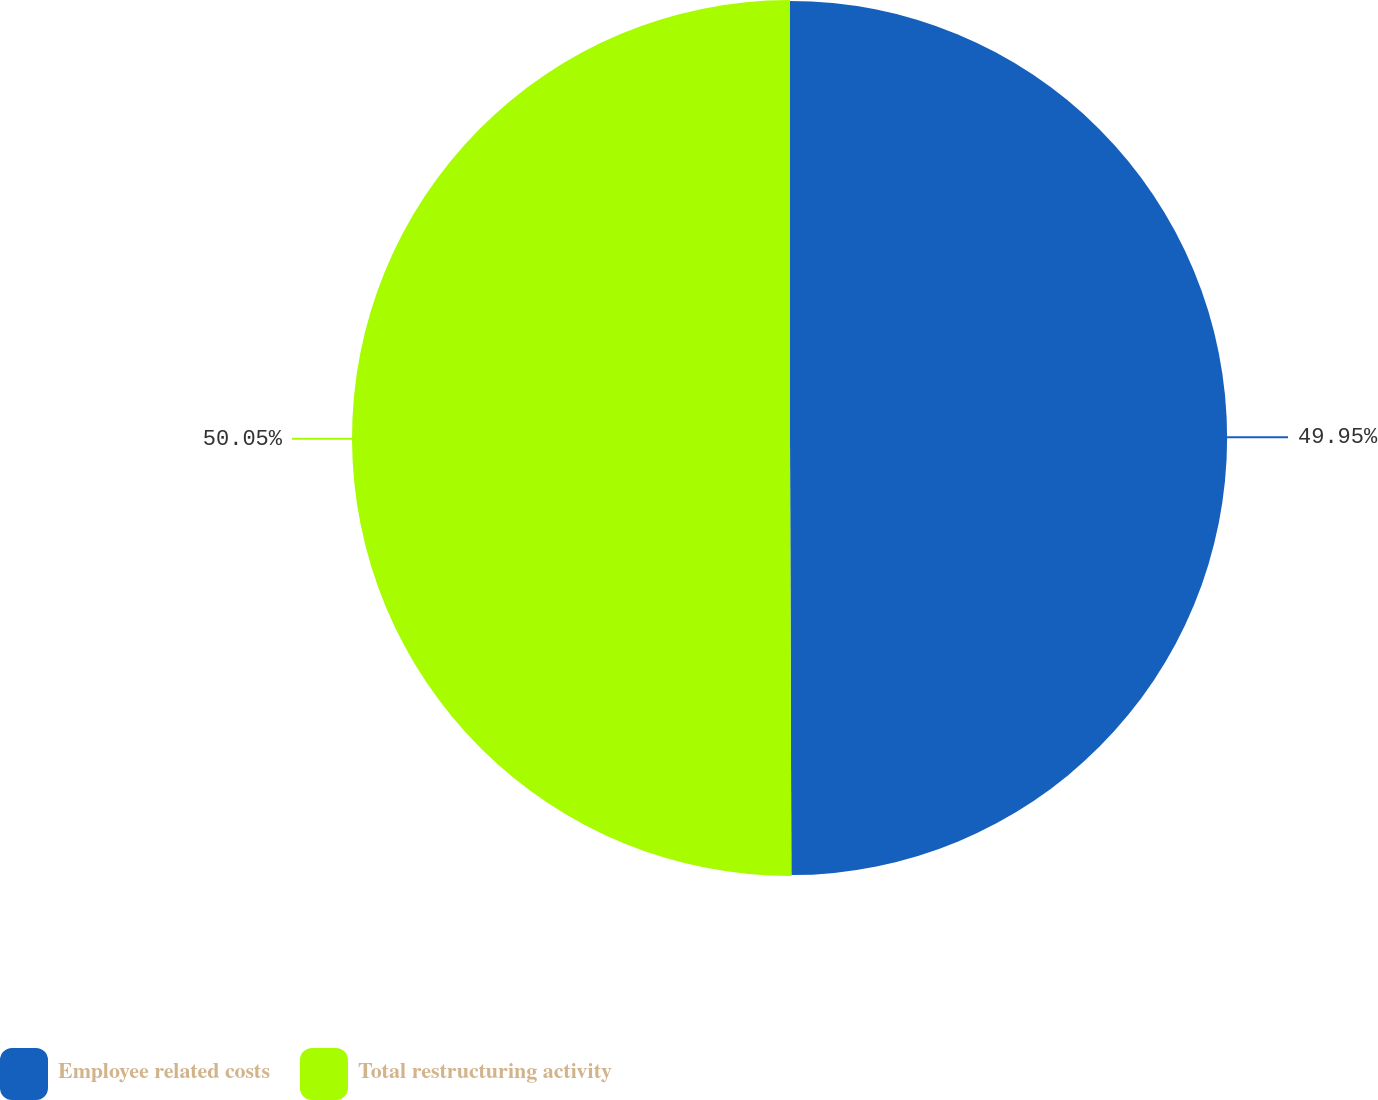<chart> <loc_0><loc_0><loc_500><loc_500><pie_chart><fcel>Employee related costs<fcel>Total restructuring activity<nl><fcel>49.95%<fcel>50.05%<nl></chart> 